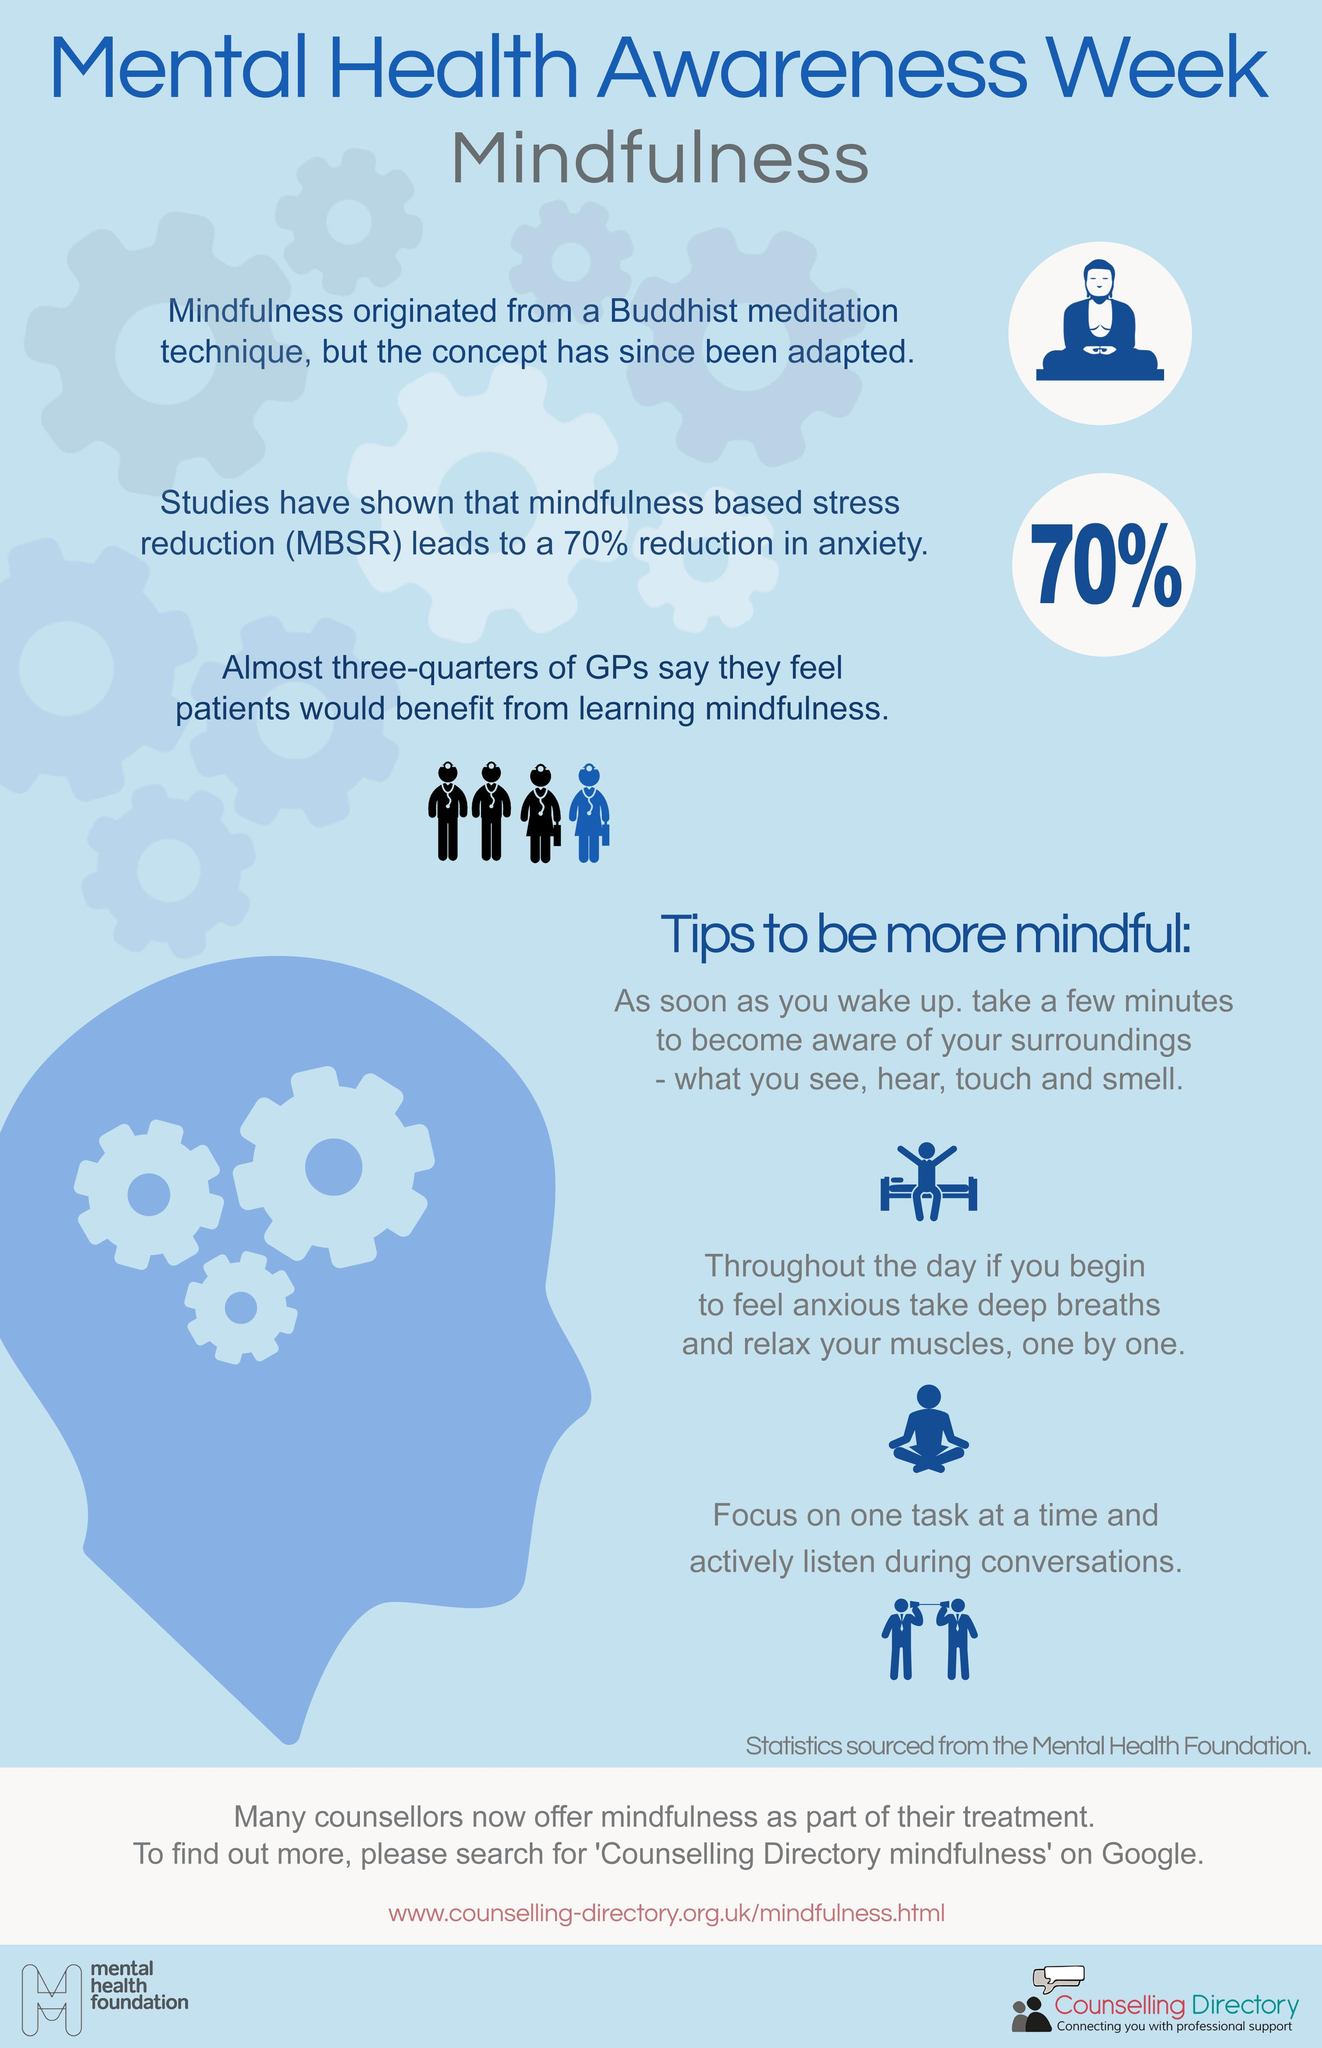From which religion does mindfulness originate - Christianity, Hinduism or Buddhism ?
Answer the question with a short phrase. Buddhism In the images representing general practitioners how many are black ? 3 What percentage of GPs say that the patient will benefit from mindfulness ? 75% Out of four GPs, how many feel that their patients will not benefit from mindfulness ? 1 